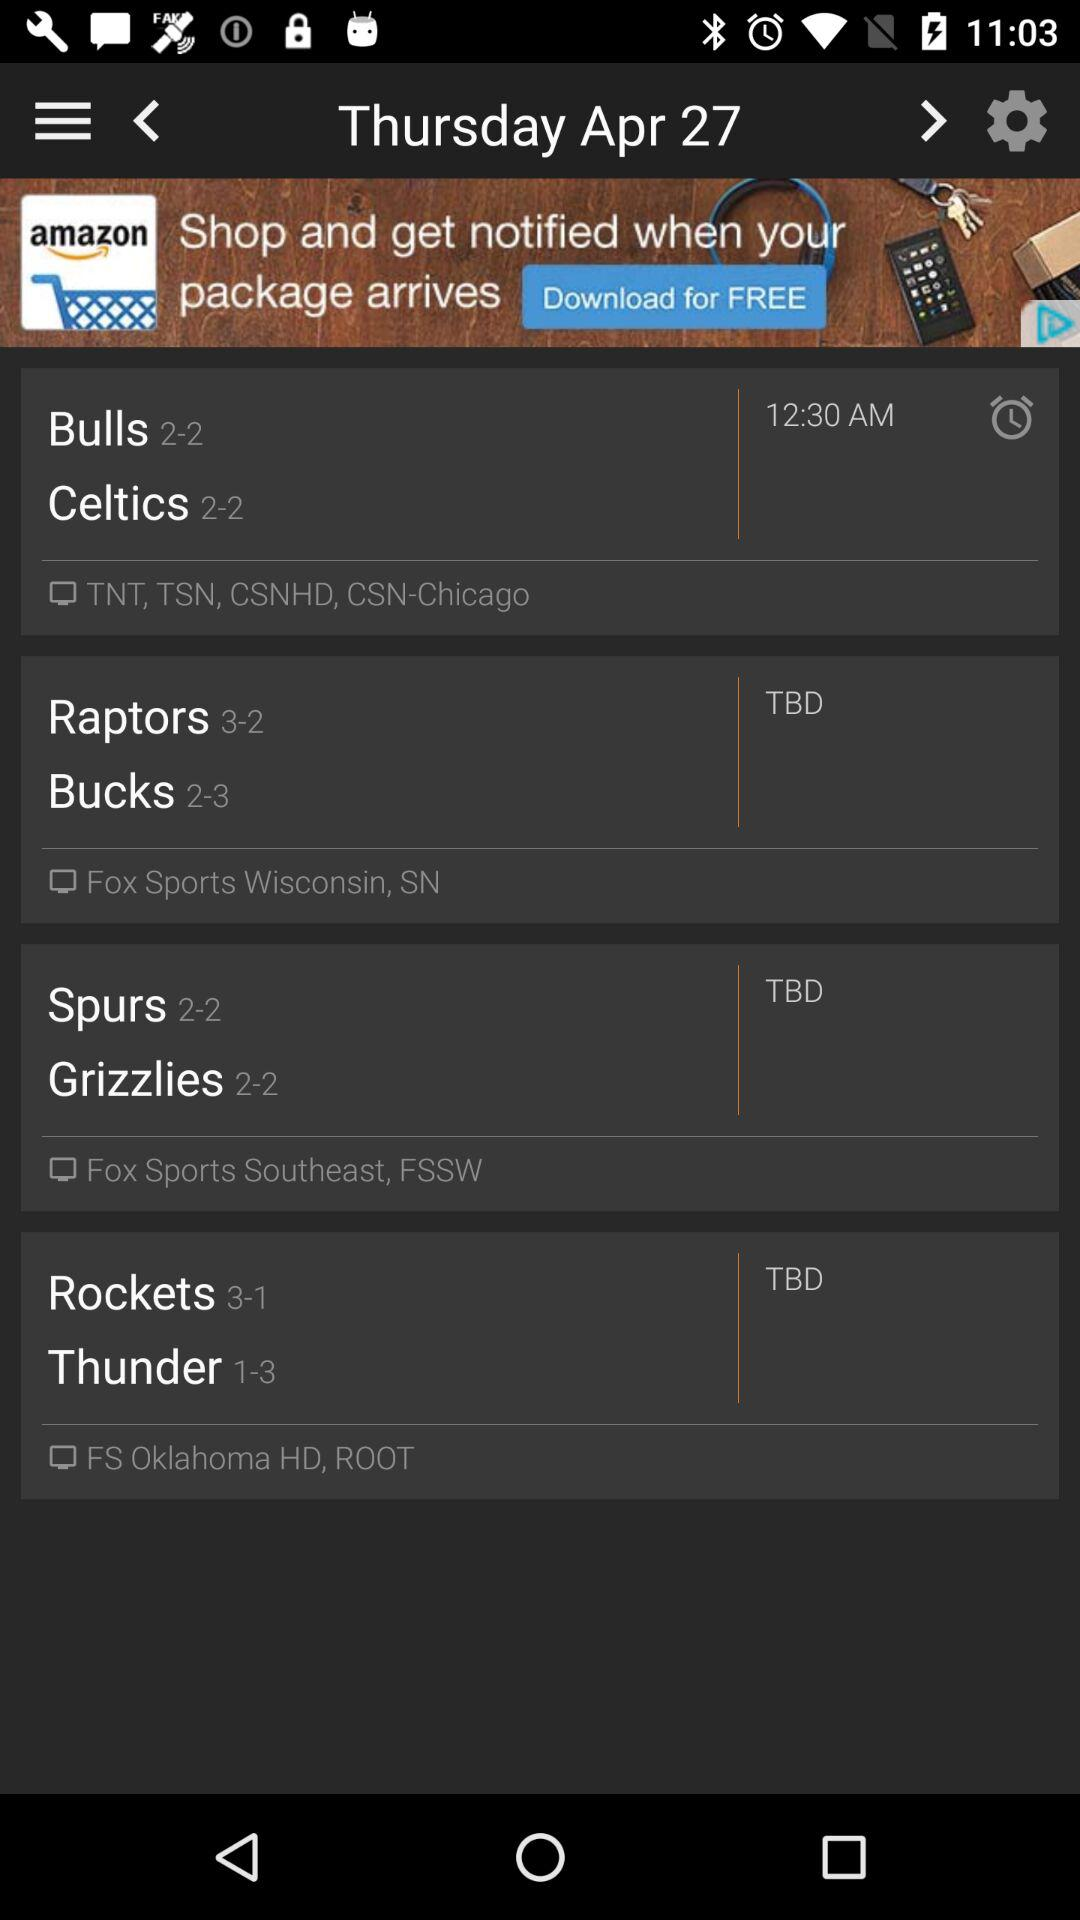What is the selected date? The selected date is "Thursday, April 27". 